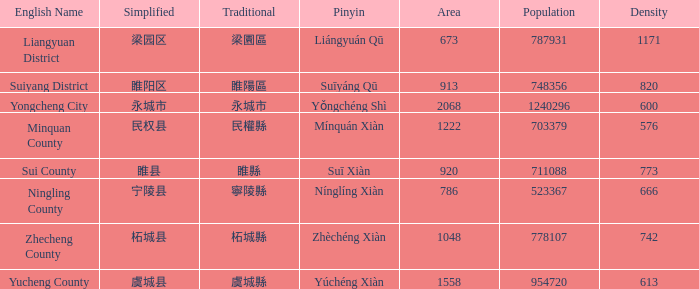What is the traditional form for 永城市? 永城市. 